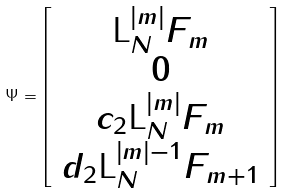<formula> <loc_0><loc_0><loc_500><loc_500>\Psi = \left [ \begin{array} { c } \text {L} _ { N } ^ { \left | m \right | } F _ { m } \\ 0 \\ c _ { 2 } \text {L} _ { N } ^ { \left | m \right | } F _ { m } \\ d _ { 2 } \text {L} _ { N } ^ { \left | m \right | - 1 } F _ { m + 1 } \end{array} \right ]</formula> 